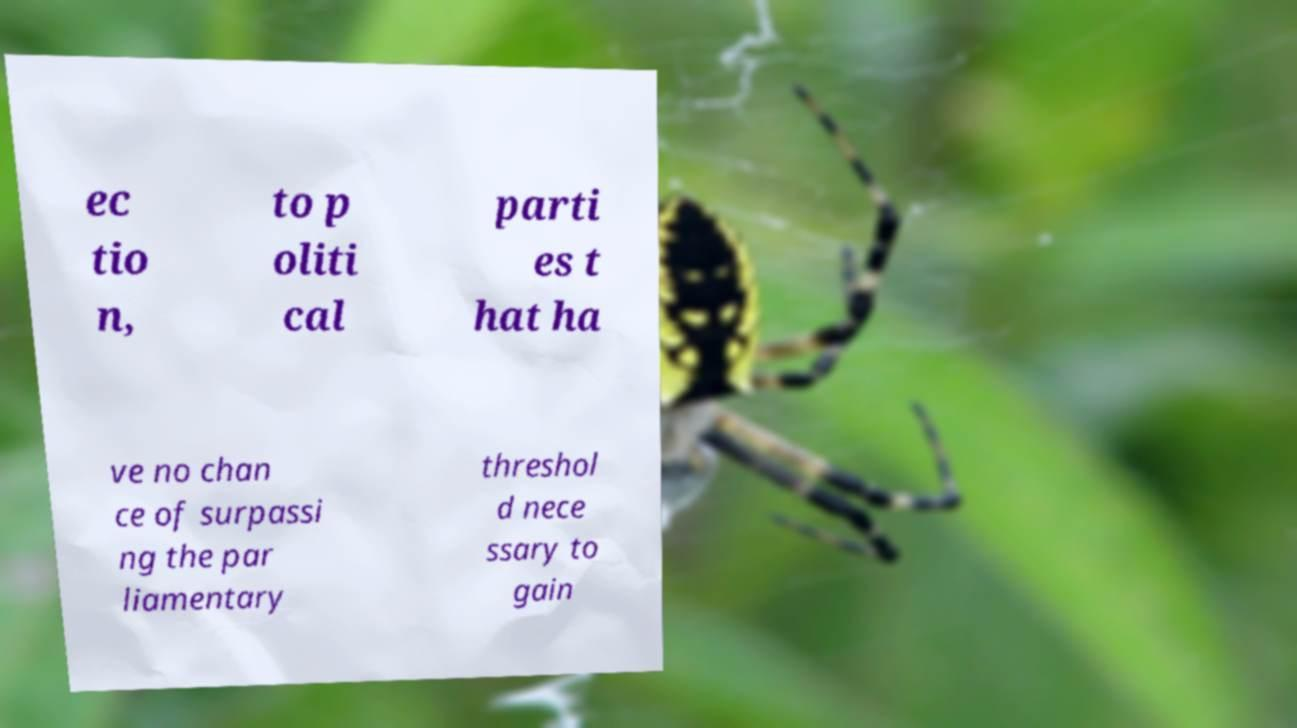Please read and relay the text visible in this image. What does it say? ec tio n, to p oliti cal parti es t hat ha ve no chan ce of surpassi ng the par liamentary threshol d nece ssary to gain 